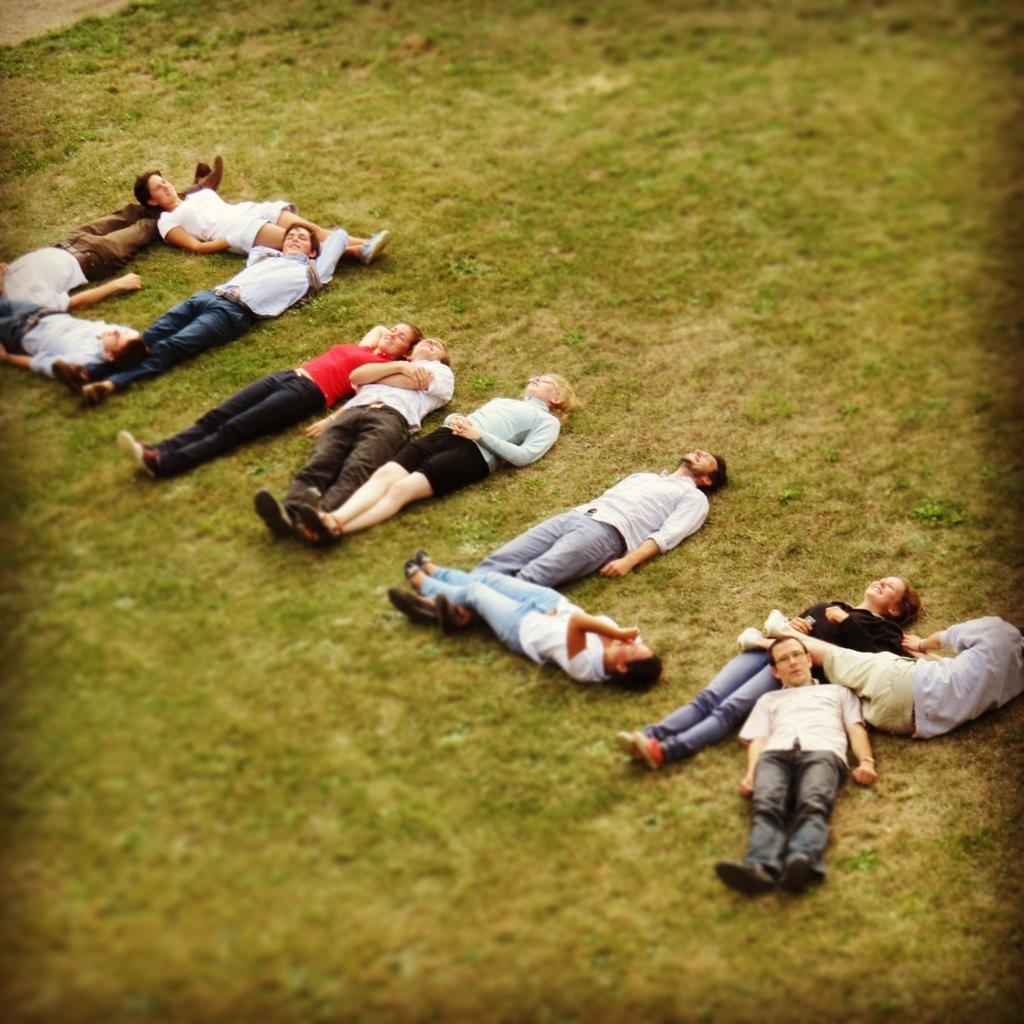Could you give a brief overview of what you see in this image? In this image we can see some people lying on the ground. 